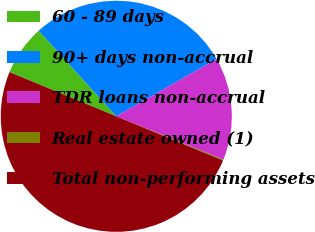Convert chart to OTSL. <chart><loc_0><loc_0><loc_500><loc_500><pie_chart><fcel>60 - 89 days<fcel>90+ days non-accrual<fcel>TDR loans non-accrual<fcel>Real estate owned (1)<fcel>Total non-performing assets<nl><fcel>7.03%<fcel>28.46%<fcel>14.37%<fcel>0.14%<fcel>50.0%<nl></chart> 